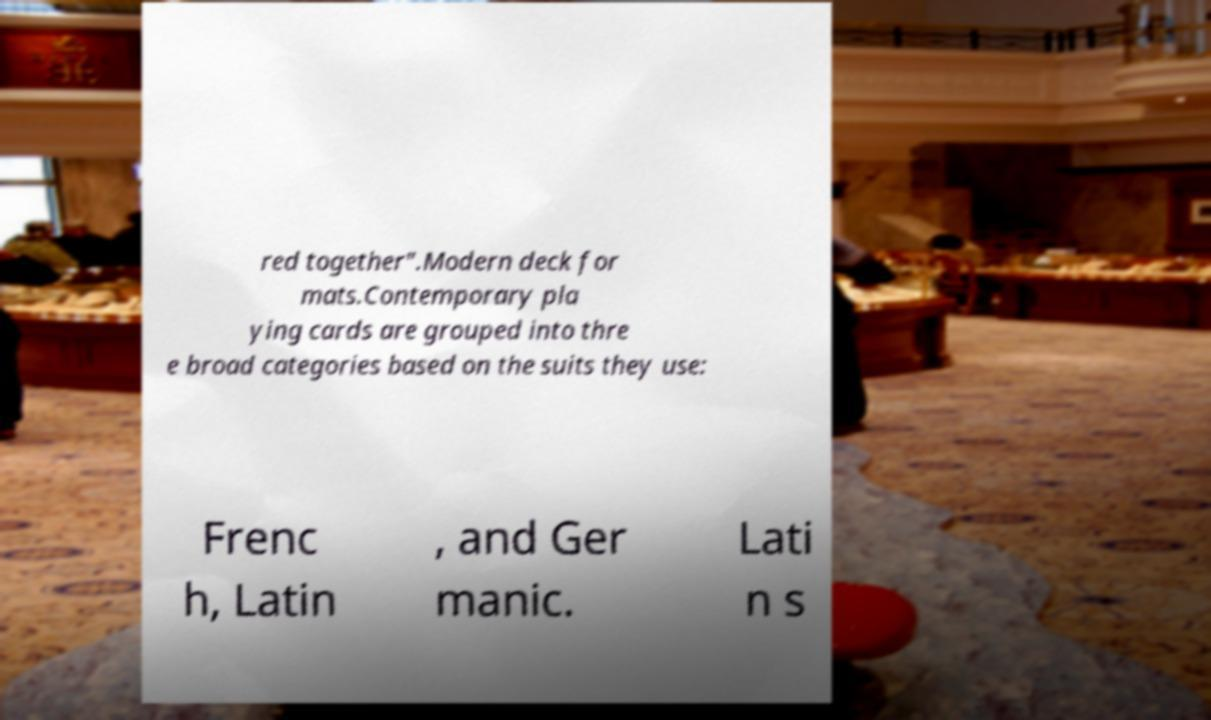Can you accurately transcribe the text from the provided image for me? red together".Modern deck for mats.Contemporary pla ying cards are grouped into thre e broad categories based on the suits they use: Frenc h, Latin , and Ger manic. Lati n s 